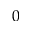<formula> <loc_0><loc_0><loc_500><loc_500>0</formula> 